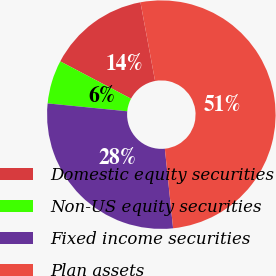Convert chart to OTSL. <chart><loc_0><loc_0><loc_500><loc_500><pie_chart><fcel>Domestic equity securities<fcel>Non-US equity securities<fcel>Fixed income securities<fcel>Plan assets<nl><fcel>14.36%<fcel>6.15%<fcel>28.21%<fcel>51.28%<nl></chart> 